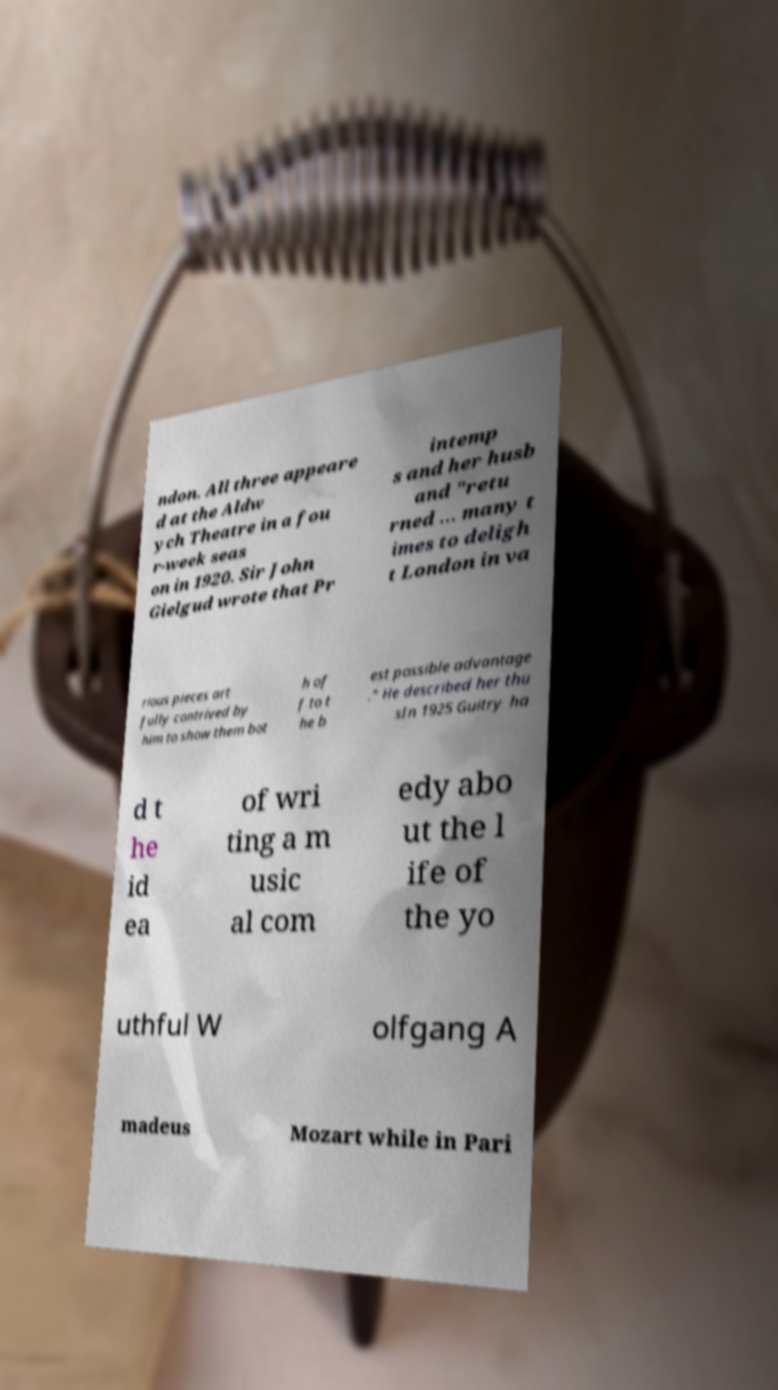Please read and relay the text visible in this image. What does it say? ndon. All three appeare d at the Aldw ych Theatre in a fou r-week seas on in 1920. Sir John Gielgud wrote that Pr intemp s and her husb and "retu rned … many t imes to deligh t London in va rious pieces art fully contrived by him to show them bot h of f to t he b est possible advantage ." He described her thu sIn 1925 Guitry ha d t he id ea of wri ting a m usic al com edy abo ut the l ife of the yo uthful W olfgang A madeus Mozart while in Pari 